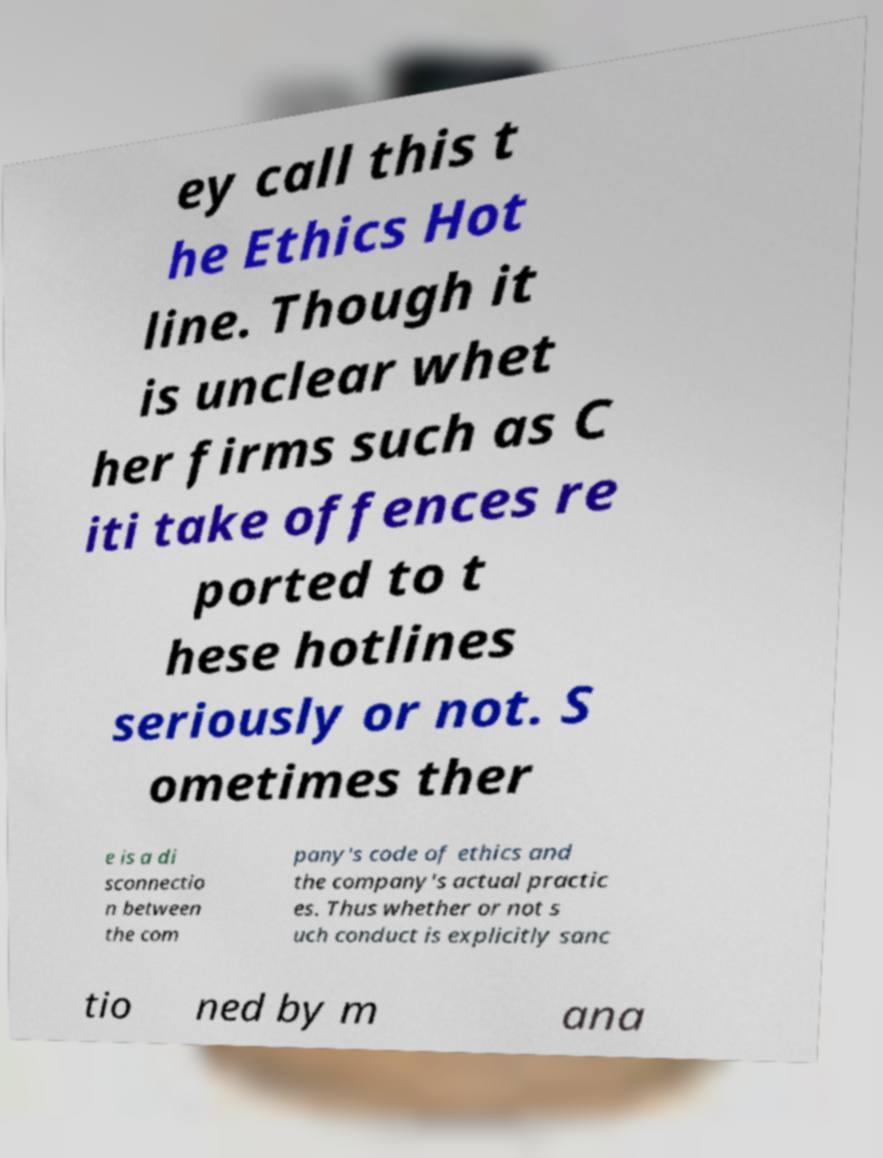Please read and relay the text visible in this image. What does it say? ey call this t he Ethics Hot line. Though it is unclear whet her firms such as C iti take offences re ported to t hese hotlines seriously or not. S ometimes ther e is a di sconnectio n between the com pany's code of ethics and the company's actual practic es. Thus whether or not s uch conduct is explicitly sanc tio ned by m ana 